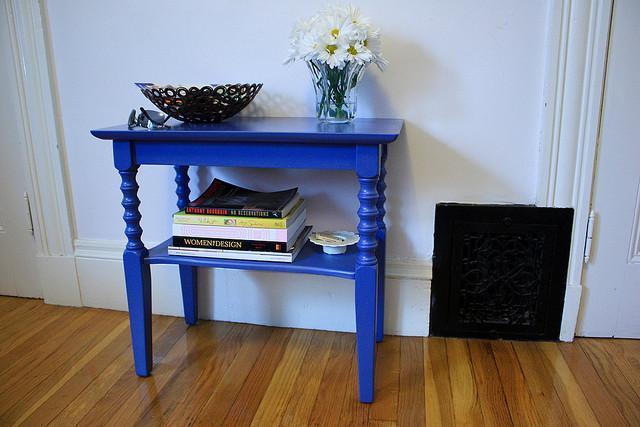How many vases are there?
Give a very brief answer. 1. How many kites are up in the air?
Give a very brief answer. 0. 